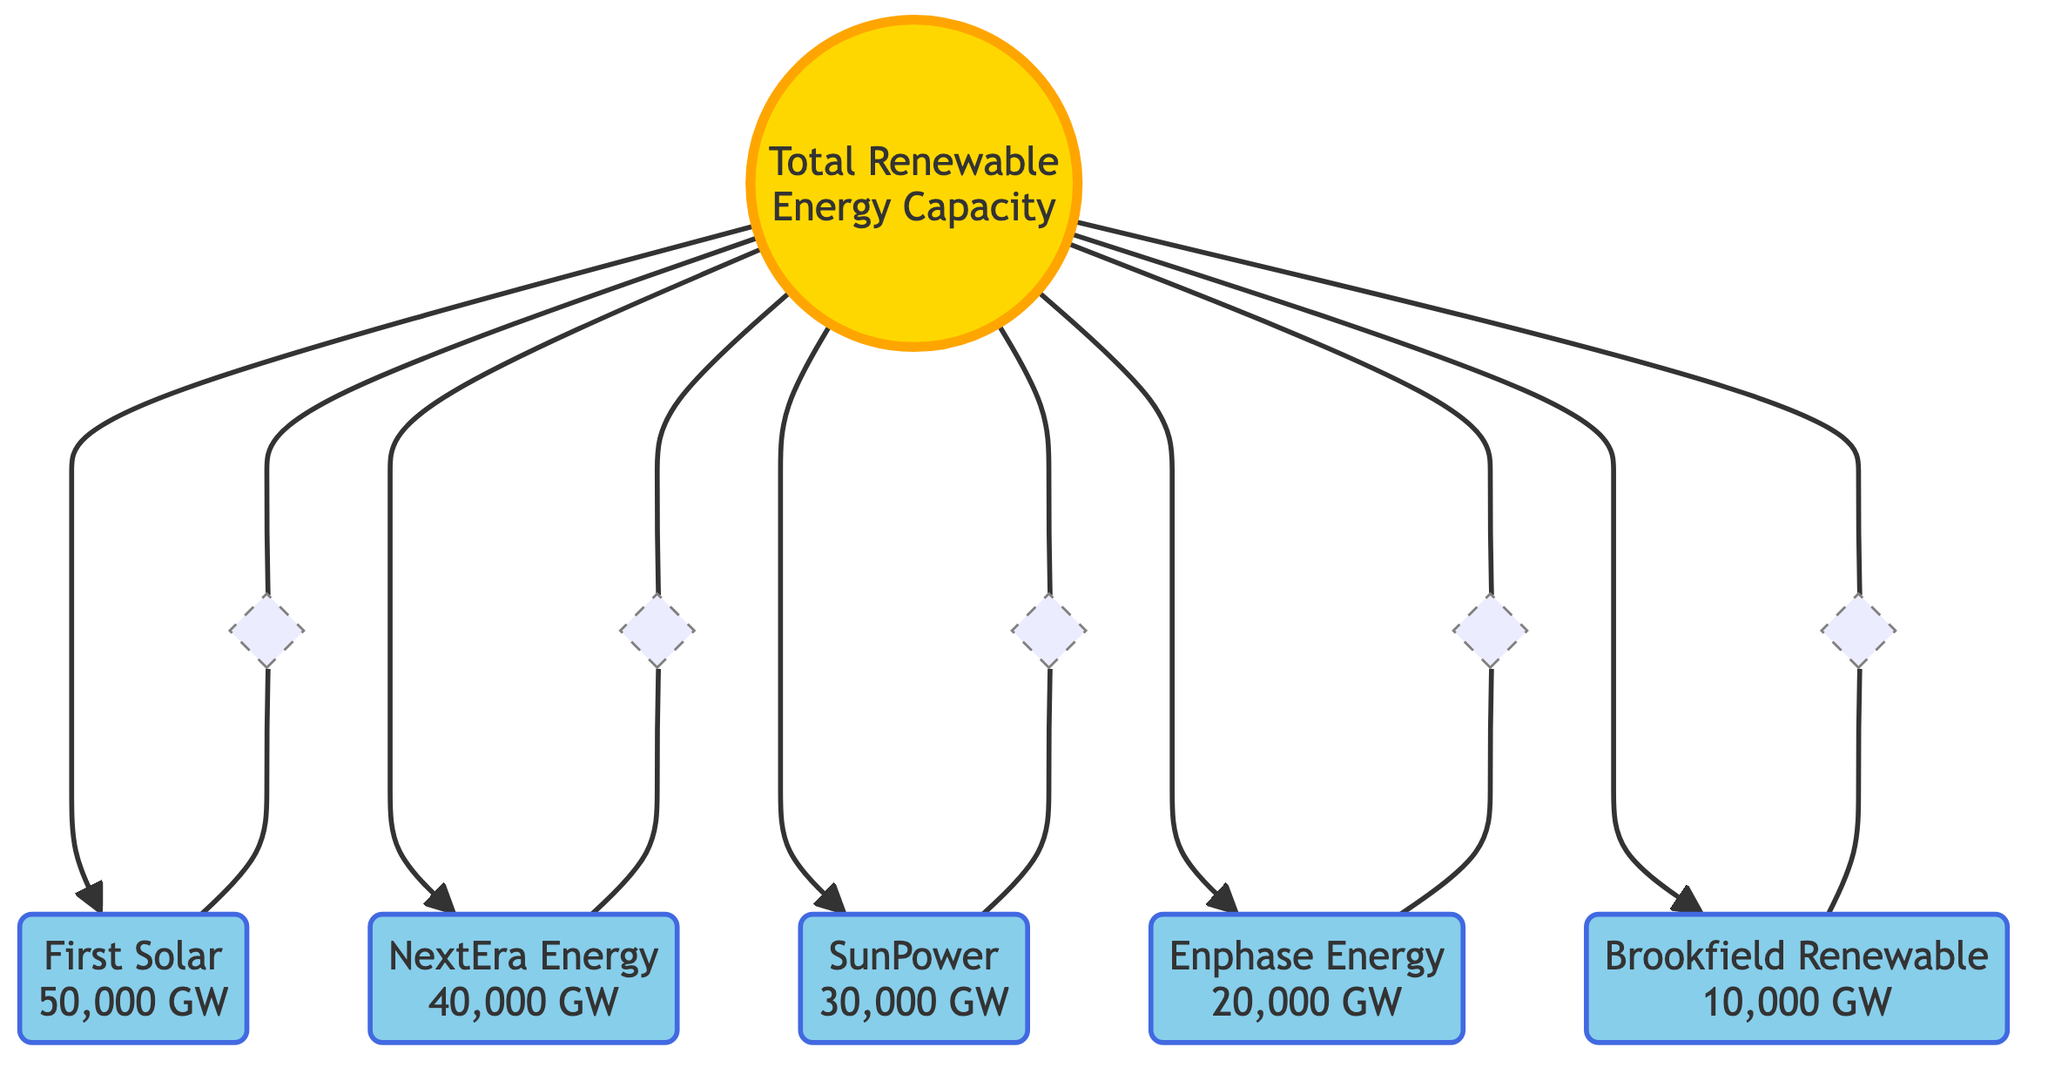What is the total renewable energy capacity of First Solar? The diagram explicitly shows that First Solar has a renewable energy capacity of 50,000 GW listed directly next to its name.
Answer: 50,000 GW Which company has the second highest capacity after First Solar? First Solar has the highest capacity at 50,000 GW, and NextEra Energy is directly connected next to it with the second highest capacity of 40,000 GW.
Answer: NextEra Energy How many companies are represented in the diagram? The diagram lists five companies: First Solar, NextEra Energy, SunPower, Enphase Energy, and Brookfield Renewable, which can be counted directly from the nodes.
Answer: 5 What is the renewable energy capacity of Enphase Energy? Enphase Energy is connected to the solar system model and is directly labeled with a renewable energy capacity of 20,000 GW.
Answer: 20,000 GW Which orbital position corresponds to Brookfield Renewable? The diagram shows Brookfield Renewable in Orbit 1, which is the innermost orbit surrounding the sun node, indicating its position in relation to other companies.
Answer: Orbit 1 What is the difference in renewable energy capacity between NextEra Energy and Brookfield Renewable? NextEra Energy has a capacity of 40,000 GW, and Brookfield Renewable has a capacity of 10,000 GW. The difference can be calculated by subtracting 10,000 from 40,000, leading to the result of 30,000 GW.
Answer: 30,000 GW Which company has the lowest renewable energy capacity? The diagram clearly demonstrates that Brookfield Renewable has the lowest capacity, with a value of 10,000 GW, as it is the last company listed and situated closest to the furthest orbit from the sun node.
Answer: Brookfield Renewable In which orbit is SunPower located? According to the diagram, SunPower is placed in Orbit 3, as it is the third company indicated in the representation of orbits surrounding the sun.
Answer: Orbit 3 What color represents the companies in the diagram? The companies are represented in a blue color denoted by the class definition "planet", specifically a light blue shade (#87CEEB).
Answer: Blue 